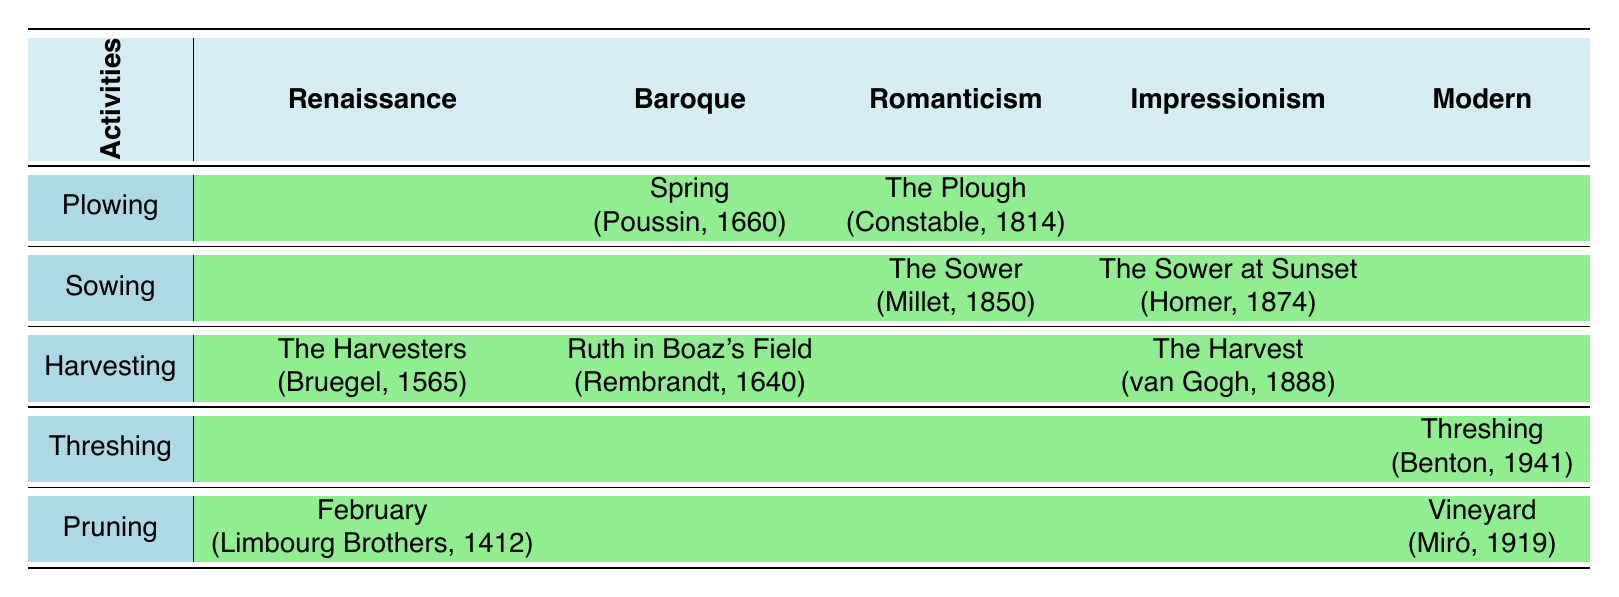What artwork represents the activity of harvesting in the Renaissance period? In the table, the Renaissance period includes the artwork "The Harvesters" by Pieter Bruegel the Elder, which depicts the activity of harvesting.
Answer: The Harvesters Which artist created a piece related to the activity of sowing during Romanticism? The table shows that Jean-François Millet created "The Sower" in 1850, which is categorized under the Romanticism period for the activity of sowing.
Answer: Jean-François Millet Is there any artwork depicting the activity of pruning from the Baroque period? Referring to the table, there are no artworks listed under the Baroque period for the activity of pruning, indicating that it does not exist for that specific period.
Answer: No Which activity is represented by Thomas Hart Benton in the Modern period? According to the table, Thomas Hart Benton created "Threshing" in 1941, which showcases the activity of threshing during the Modern period.
Answer: Threshing How many activities are depicted in the table for the Impressionism period? The table lists four activities for the Impressionism period: harvesting and sowing. Thus, the total is two activities represented in this style.
Answer: 2 Which period has the earliest artwork related to the activity of plowing? In the table, the earliest artwork for the activity of plowing is "The Plough" by John Constable, created in 1814 during the Romanticism period, which comes after the Renaissance and Baroque.
Answer: Romanticism Are there more artworks related to harvesting or sowing across all periods? The table shows four artworks related to harvesting (two from Renaissance, one from Baroque, one from Impressionism) and two related to sowing (one from Romanticism, one from Impressionism). Therefore, harvesting has more artworks.
Answer: Harvesting What is the title of the piece by the Limbourg Brothers and what activity does it represent? According to the table, the piece by the Limbourg Brothers is titled "February," and it represents the activity of pruning during the Renaissance period.
Answer: February, Pruning Which artistic period does not include any art for the activity of sowing? By checking the table, we find that the Baroque and Modern periods do not have any artworks listed for the activity of sowing, indicating both periods lack this representation.
Answer: Baroque, Modern Compare the years of artworks depicting pruning in the Renaissance and Modern periods. The Renaissance artwork "February" by the Limbourg Brothers is from 1412, while the Modern artwork "Vineyard" by Joan Miró is from 1919. Thus, the year difference is 1919 - 1412 = 507 years, showing that Modern pruning is much later.
Answer: 507 years difference 